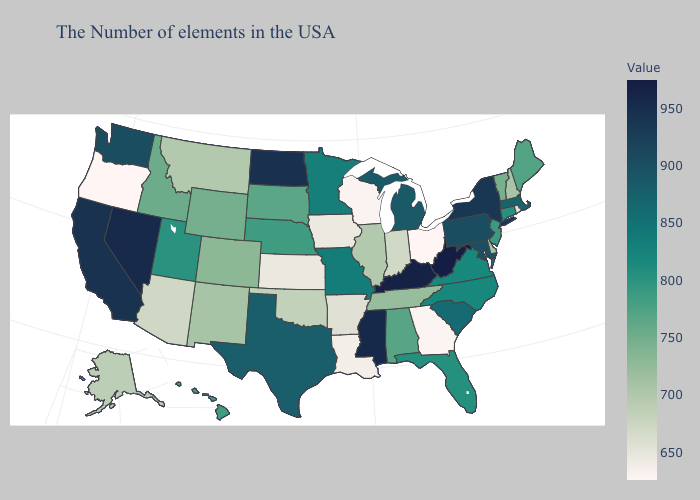Does North Carolina have a higher value than Kentucky?
Keep it brief. No. Does Oregon have the lowest value in the USA?
Quick response, please. Yes. Which states have the lowest value in the MidWest?
Answer briefly. Ohio. Which states have the lowest value in the USA?
Short answer required. Ohio, Oregon. Which states hav the highest value in the South?
Give a very brief answer. West Virginia. Which states have the highest value in the USA?
Write a very short answer. West Virginia. Among the states that border Ohio , does Indiana have the lowest value?
Quick response, please. Yes. 